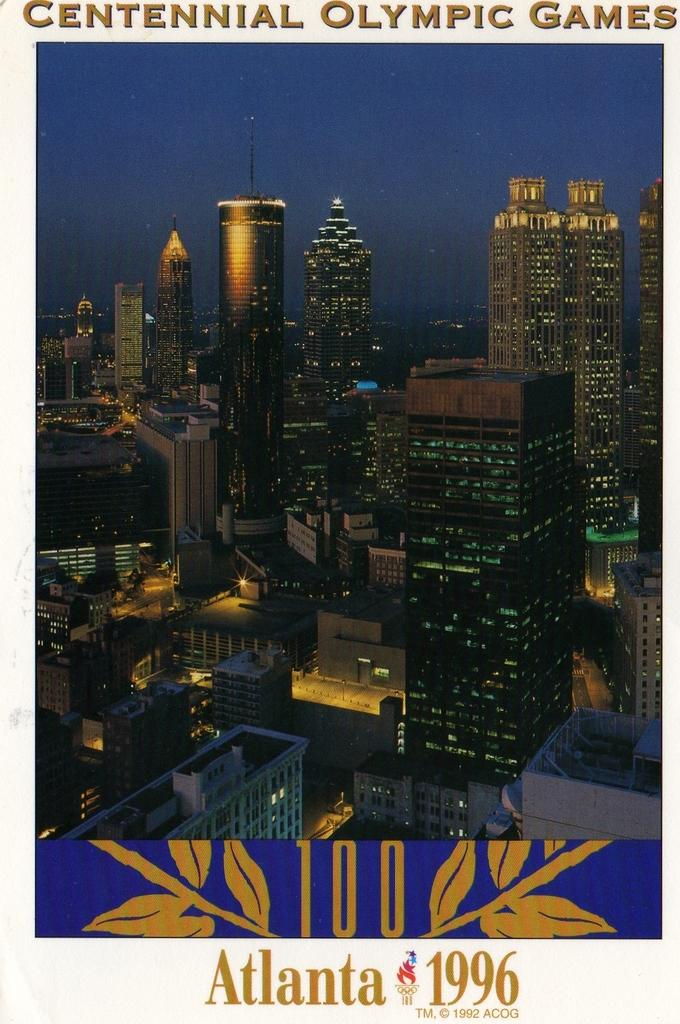What is the main subject of the poster in the image? The poster contains images of buildings and lights. What is the color of the sky in the background of the poster? The sky in the background of the poster is dark. Is there any text on the poster? Yes, there is text on the poster. What type of meal is being served on the poster? There is no meal depicted on the poster; it features images of buildings and lights. How many feet are visible on the poster? There are no feet visible on the poster. 